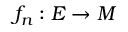<formula> <loc_0><loc_0><loc_500><loc_500>f _ { n } \colon E \to M</formula> 